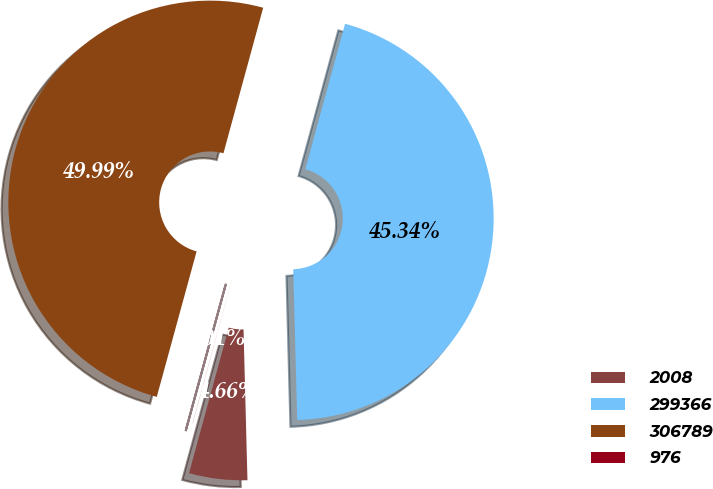Convert chart. <chart><loc_0><loc_0><loc_500><loc_500><pie_chart><fcel>2008<fcel>299366<fcel>306789<fcel>976<nl><fcel>4.66%<fcel>45.34%<fcel>49.99%<fcel>0.01%<nl></chart> 